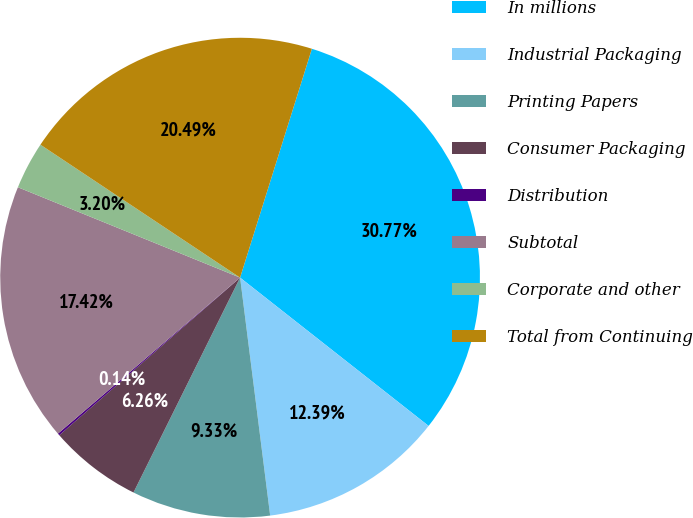Convert chart to OTSL. <chart><loc_0><loc_0><loc_500><loc_500><pie_chart><fcel>In millions<fcel>Industrial Packaging<fcel>Printing Papers<fcel>Consumer Packaging<fcel>Distribution<fcel>Subtotal<fcel>Corporate and other<fcel>Total from Continuing<nl><fcel>30.77%<fcel>12.39%<fcel>9.33%<fcel>6.26%<fcel>0.14%<fcel>17.42%<fcel>3.2%<fcel>20.49%<nl></chart> 